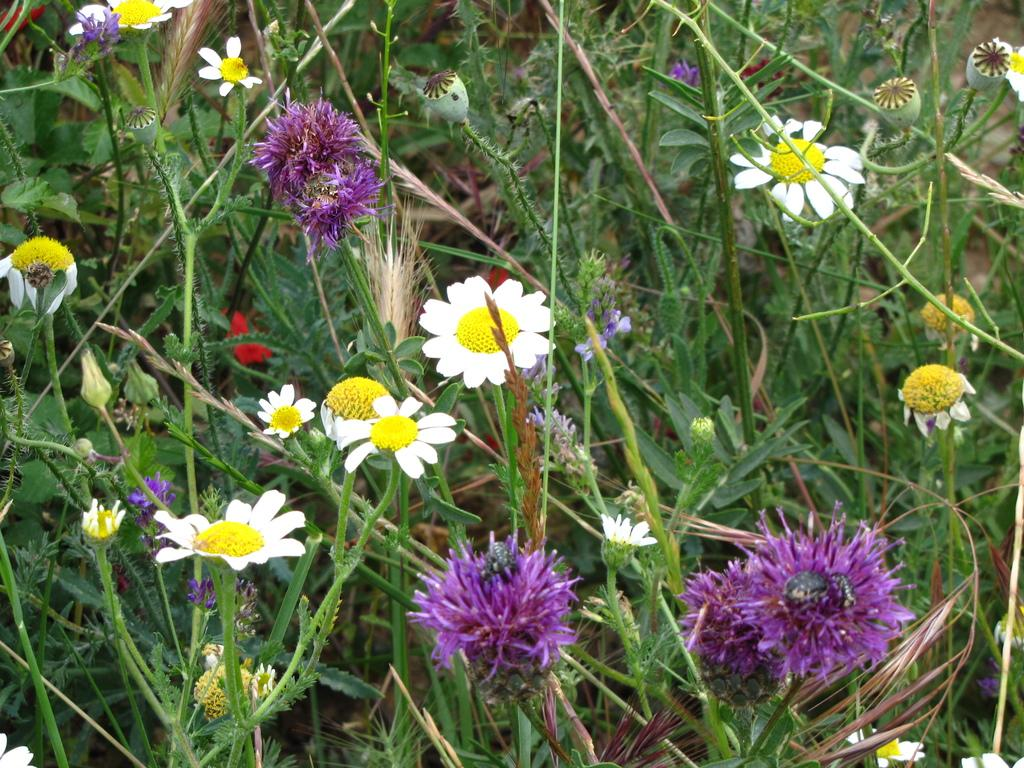What type of living organisms can be seen in the image? Plants can be seen in the image. What colors are the flowers in the image? There are purple and white color flowers in the image. What type of oatmeal is being served in the image? There is no oatmeal present in the image; it features plants with purple and white flowers. 